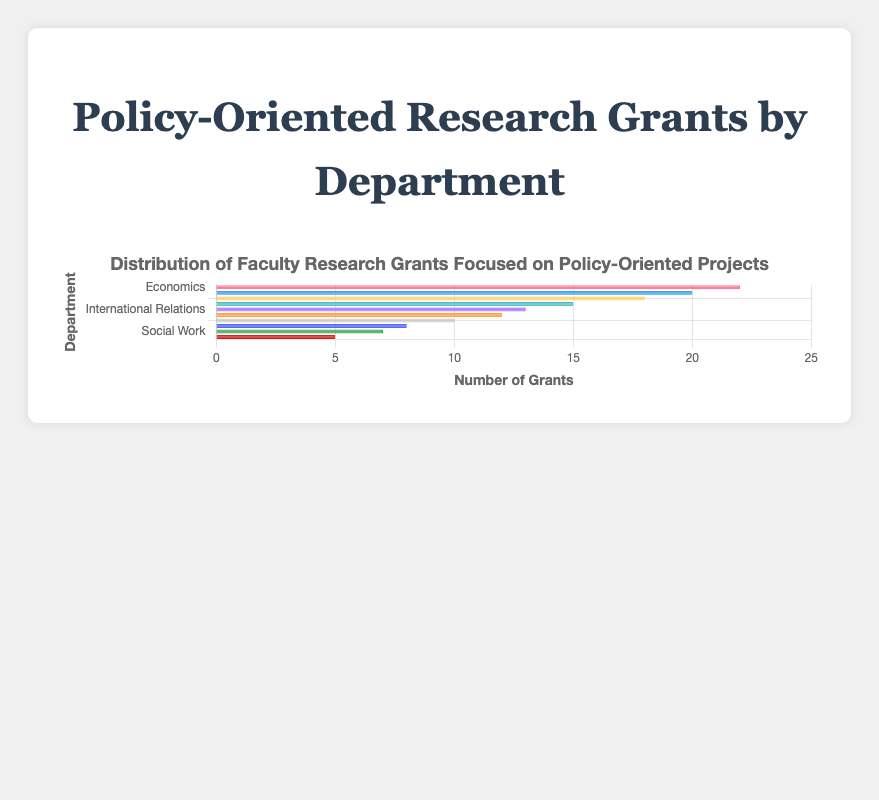Which department has the highest number of policy-focused research grants? Look at the lengths of the bars in the figure. The longest bar represents the department with the highest number of grants.
Answer: Economics Which department has the lowest number of policy-focused research grants? Look at the lengths of the bars in the figure. The shortest bar represents the department with the lowest number of grants.
Answer: Urban Studies How many more policy-focused grants does the Political Science department have compared to the Social Work department? Refer to the bar lengths for both departments. Political Science has 18 grants, and Social Work has 7 grants. Subtract 7 from 18.
Answer: 11 What is the total number of policy-focused research grants across all departments? Sum the number of grants from each department: 22 (Economics) + 20 (Law) + 18 (Political Science) + 15 (Public Health) + 13 (International Relations) + 12 (Education) + 10 (Sociology) + 8 (Environmental Science) + 7 (Social Work) + 5 (Urban Studies) = 130.
Answer: 130 Which department has slightly fewer policy-focused research grants than the Law department? Look at the figure for the bar representing Law with 20 grants, and find the bar representing the department with one step lower in quantity.
Answer: Political Science Are the number of grants in the Public Health department greater than, less than, or equal to those in the Education department? Compare the length of the bars for Public Health and Education. Public Health has 15 grants, and Education has 12 grants.
Answer: Greater than What is the average number of policy-focused research grants per department? First, calculate the total number of grants (130) and then divide it by the number of departments (10). 130 / 10 = 13.
Answer: 13 How many departments have more than 15 policy-focused research grants? Identify the departments with more than 15 grants by looking at the bar lengths: Economics (22), Law (20), and Political Science (18).
Answer: 3 Is the number of policy-focused research grants in the Sociology department closer to that of the Education or Environmental Science department? Compare the number of grants in Sociology (10) with Education (12) and Environmental Science (8). The difference with Education is 2 (12-10) and with Environmental Science is 2 (10-8).
Answer: Equally close to both Which department's bar is colored blue, and what is their number of grants? Look at the bar colors. The blue bar represents the Law department, which has 20 grants.
Answer: Law, 20 